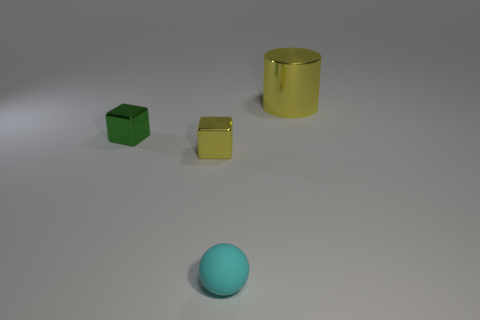Add 2 cyan rubber things. How many objects exist? 6 Subtract 1 balls. How many balls are left? 0 Subtract all cylinders. How many objects are left? 3 Subtract all gray cylinders. How many green cubes are left? 1 Subtract 0 yellow spheres. How many objects are left? 4 Subtract all yellow balls. Subtract all purple cylinders. How many balls are left? 1 Subtract all big gray cylinders. Subtract all big cylinders. How many objects are left? 3 Add 1 tiny cyan spheres. How many tiny cyan spheres are left? 2 Add 2 small brown balls. How many small brown balls exist? 2 